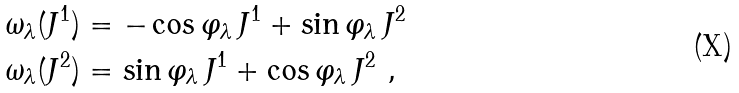<formula> <loc_0><loc_0><loc_500><loc_500>\omega _ { \lambda } ( J ^ { 1 } ) & = - \cos \varphi _ { \lambda } \, J ^ { 1 } + \sin \varphi _ { \lambda } \, J ^ { 2 } \\ \omega _ { \lambda } ( J ^ { 2 } ) & = \sin \varphi _ { \lambda } \, J ^ { 1 } + \cos \varphi _ { \lambda } \, J ^ { 2 } \ ,</formula> 